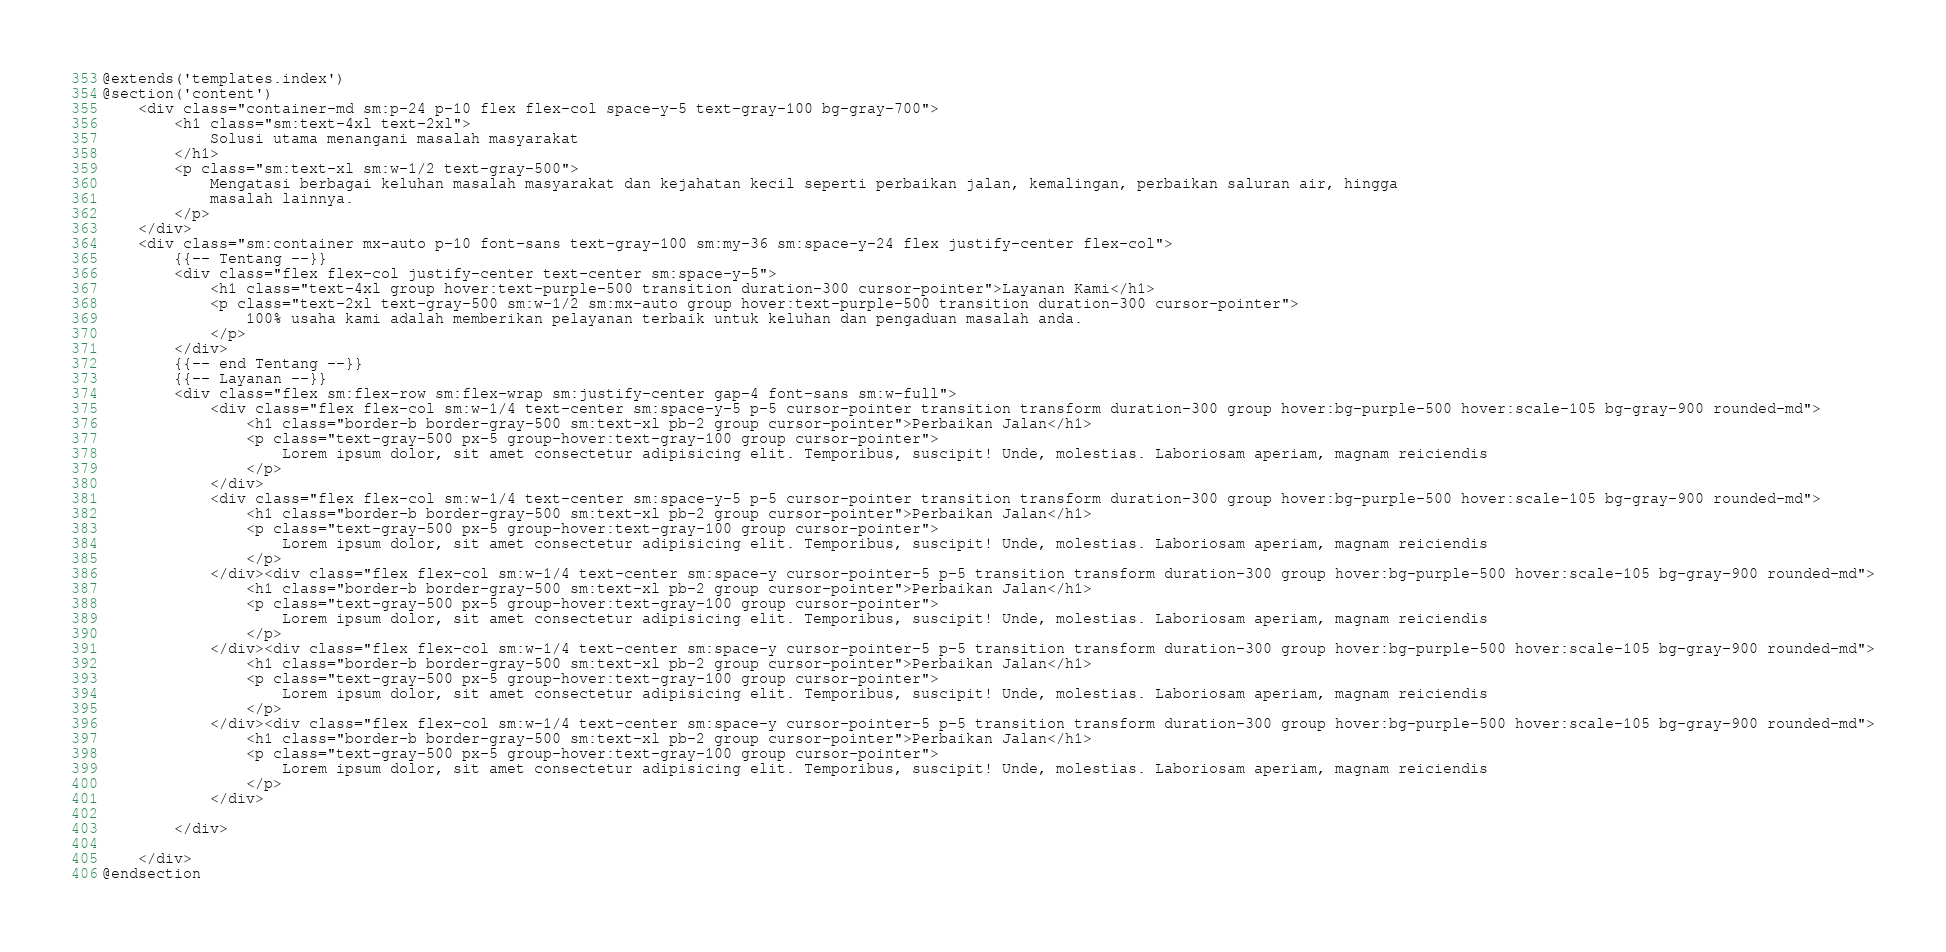Convert code to text. <code><loc_0><loc_0><loc_500><loc_500><_PHP_>@extends('templates.index')
@section('content')
    <div class="container-md sm:p-24 p-10 flex flex-col space-y-5 text-gray-100 bg-gray-700">
        <h1 class="sm:text-4xl text-2xl">
            Solusi utama menangani masalah masyarakat
        </h1>
        <p class="sm:text-xl sm:w-1/2 text-gray-500">
            Mengatasi berbagai keluhan masalah masyarakat dan kejahatan kecil seperti perbaikan jalan, kemalingan, perbaikan saluran air, hingga
            masalah lainnya.
        </p>
    </div>
    <div class="sm:container mx-auto p-10 font-sans text-gray-100 sm:my-36 sm:space-y-24 flex justify-center flex-col">
        {{-- Tentang --}}
        <div class="flex flex-col justify-center text-center sm:space-y-5">
            <h1 class="text-4xl group hover:text-purple-500 transition duration-300 cursor-pointer">Layanan Kami</h1>
            <p class="text-2xl text-gray-500 sm:w-1/2 sm:mx-auto group hover:text-purple-500 transition duration-300 cursor-pointer">
                100% usaha kami adalah memberikan pelayanan terbaik untuk keluhan dan pengaduan masalah anda.
            </p>
        </div>
        {{-- end Tentang --}}
        {{-- Layanan --}}
        <div class="flex sm:flex-row sm:flex-wrap sm:justify-center gap-4 font-sans sm:w-full">
            <div class="flex flex-col sm:w-1/4 text-center sm:space-y-5 p-5 cursor-pointer transition transform duration-300 group hover:bg-purple-500 hover:scale-105 bg-gray-900 rounded-md">
                <h1 class="border-b border-gray-500 sm:text-xl pb-2 group cursor-pointer">Perbaikan Jalan</h1>
                <p class="text-gray-500 px-5 group-hover:text-gray-100 group cursor-pointer">
                    Lorem ipsum dolor, sit amet consectetur adipisicing elit. Temporibus, suscipit! Unde, molestias. Laboriosam aperiam, magnam reiciendis
                </p>
            </div>
            <div class="flex flex-col sm:w-1/4 text-center sm:space-y-5 p-5 cursor-pointer transition transform duration-300 group hover:bg-purple-500 hover:scale-105 bg-gray-900 rounded-md">
                <h1 class="border-b border-gray-500 sm:text-xl pb-2 group cursor-pointer">Perbaikan Jalan</h1>
                <p class="text-gray-500 px-5 group-hover:text-gray-100 group cursor-pointer">
                    Lorem ipsum dolor, sit amet consectetur adipisicing elit. Temporibus, suscipit! Unde, molestias. Laboriosam aperiam, magnam reiciendis
                </p>
            </div><div class="flex flex-col sm:w-1/4 text-center sm:space-y cursor-pointer-5 p-5 transition transform duration-300 group hover:bg-purple-500 hover:scale-105 bg-gray-900 rounded-md">
                <h1 class="border-b border-gray-500 sm:text-xl pb-2 group cursor-pointer">Perbaikan Jalan</h1>
                <p class="text-gray-500 px-5 group-hover:text-gray-100 group cursor-pointer">
                    Lorem ipsum dolor, sit amet consectetur adipisicing elit. Temporibus, suscipit! Unde, molestias. Laboriosam aperiam, magnam reiciendis
                </p>
            </div><div class="flex flex-col sm:w-1/4 text-center sm:space-y cursor-pointer-5 p-5 transition transform duration-300 group hover:bg-purple-500 hover:scale-105 bg-gray-900 rounded-md">
                <h1 class="border-b border-gray-500 sm:text-xl pb-2 group cursor-pointer">Perbaikan Jalan</h1>
                <p class="text-gray-500 px-5 group-hover:text-gray-100 group cursor-pointer">
                    Lorem ipsum dolor, sit amet consectetur adipisicing elit. Temporibus, suscipit! Unde, molestias. Laboriosam aperiam, magnam reiciendis
                </p>
            </div><div class="flex flex-col sm:w-1/4 text-center sm:space-y cursor-pointer-5 p-5 transition transform duration-300 group hover:bg-purple-500 hover:scale-105 bg-gray-900 rounded-md">
                <h1 class="border-b border-gray-500 sm:text-xl pb-2 group cursor-pointer">Perbaikan Jalan</h1>
                <p class="text-gray-500 px-5 group-hover:text-gray-100 group cursor-pointer">
                    Lorem ipsum dolor, sit amet consectetur adipisicing elit. Temporibus, suscipit! Unde, molestias. Laboriosam aperiam, magnam reiciendis
                </p>
            </div>
            
        </div>

    </div>
@endsection</code> 